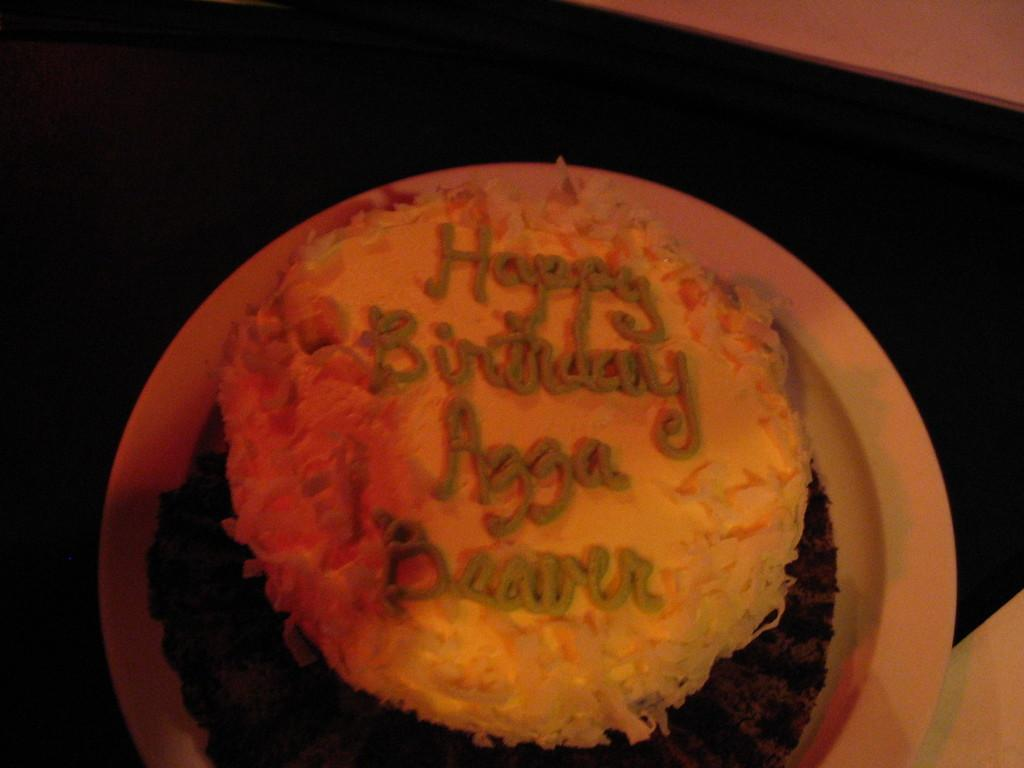What is the main subject of the image? There is a cake in the image. Where is the cake located? The cake is on a table. What can be seen on top of the cake? There is cream on the cake. What type of alarm is ringing in the image? There is no alarm present in the image; it features a cake on a table with cream on top. Can you see a vase on the table next to the cake? There is no vase mentioned or visible in the image. 